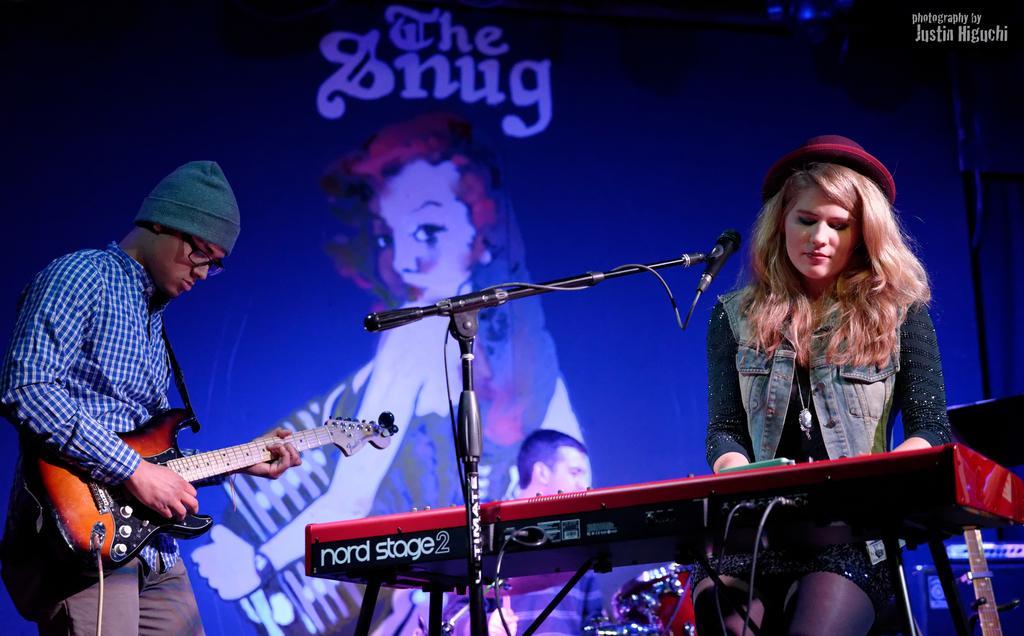Please provide a concise description of this image. In this image I can see few people where one of them is holding guitar. I can also see he is wearing specs and a cap. I can also see a mic, a drum set and a musical instrument. In the background I can see depiction of a woman and I can see something is written at few places. 